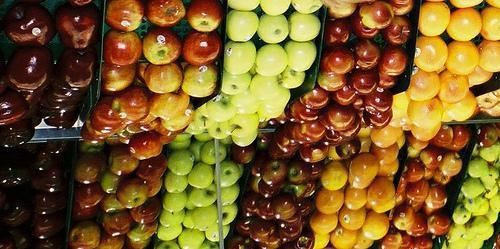How many colors of fruits?
Give a very brief answer. 4. How many apples are there?
Give a very brief answer. 8. How many people are wearing a green shirt?
Give a very brief answer. 0. 